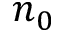Convert formula to latex. <formula><loc_0><loc_0><loc_500><loc_500>n _ { 0 }</formula> 